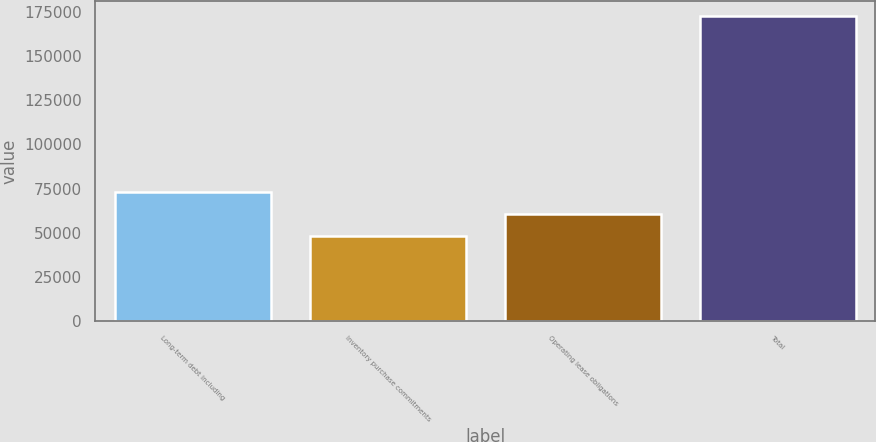Convert chart. <chart><loc_0><loc_0><loc_500><loc_500><bar_chart><fcel>Long-term debt including<fcel>Inventory purchase commitments<fcel>Operating lease obligations<fcel>Total<nl><fcel>73167.2<fcel>48339<fcel>60753.1<fcel>172480<nl></chart> 